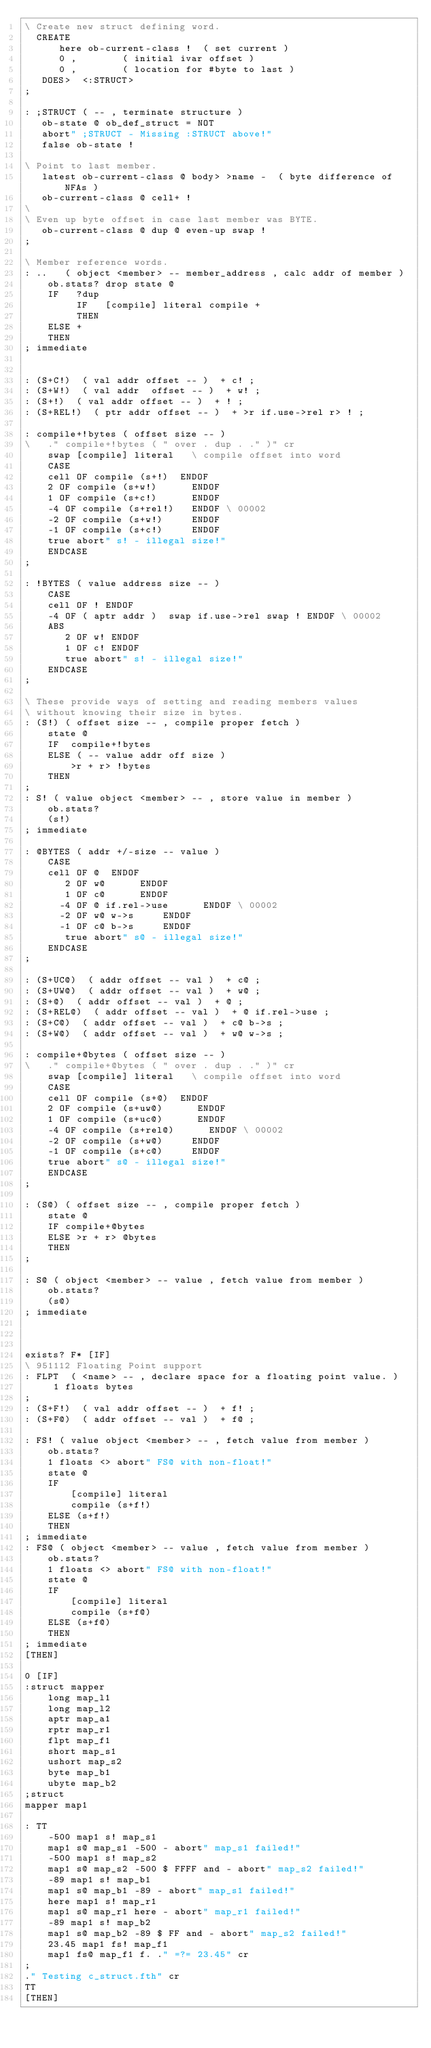Convert code to text. <code><loc_0><loc_0><loc_500><loc_500><_Forth_>\ Create new struct defining word.
  CREATE
      here ob-current-class !  ( set current )
      0 ,        ( initial ivar offset )
      0 ,        ( location for #byte to last )
   DOES>  <:STRUCT>
;

: ;STRUCT ( -- , terminate structure )
   ob-state @ ob_def_struct = NOT
   abort" ;STRUCT - Missing :STRUCT above!"
   false ob-state !

\ Point to last member.
   latest ob-current-class @ body> >name -  ( byte difference of NFAs )
   ob-current-class @ cell+ !
\
\ Even up byte offset in case last member was BYTE.
   ob-current-class @ dup @ even-up swap !
;

\ Member reference words.
: ..   ( object <member> -- member_address , calc addr of member )
    ob.stats? drop state @
    IF   ?dup
         IF   [compile] literal compile +
         THEN
    ELSE +
    THEN
; immediate


: (S+C!)  ( val addr offset -- )  + c! ;
: (S+W!)  ( val addr  offset -- )  + w! ;
: (S+!)  ( val addr offset -- )  + ! ;
: (S+REL!)  ( ptr addr offset -- )  + >r if.use->rel r> ! ;

: compile+!bytes ( offset size -- )
\	." compile+!bytes ( " over . dup . ." )" cr
	swap [compile] literal   \ compile offset into word
	CASE
	cell OF compile (s+!)  ENDOF
	2 OF compile (s+w!)      ENDOF
	1 OF compile (s+c!)      ENDOF
	-4 OF compile (s+rel!)   ENDOF \ 00002
	-2 OF compile (s+w!)     ENDOF
	-1 OF compile (s+c!)     ENDOF
	true abort" s! - illegal size!"
	ENDCASE
;

: !BYTES ( value address size -- )
    CASE
    cell OF ! ENDOF
	-4 OF ( aptr addr )  swap if.use->rel swap ! ENDOF \ 00002
	ABS
       2 OF w! ENDOF
       1 OF c! ENDOF
       true abort" s! - illegal size!"
    ENDCASE
;

\ These provide ways of setting and reading members values
\ without knowing their size in bytes.
: (S!) ( offset size -- , compile proper fetch )
	state @
    IF  compile+!bytes 
    ELSE ( -- value addr off size )
        >r + r> !bytes
    THEN
;
: S! ( value object <member> -- , store value in member )
    ob.stats?
	(s!)
; immediate

: @BYTES ( addr +/-size -- value )
    CASE
    cell OF @  ENDOF
       2 OF w@      ENDOF
       1 OF c@      ENDOF
      -4 OF @ if.rel->use      ENDOF \ 00002
      -2 OF w@ w->s     ENDOF
      -1 OF c@ b->s     ENDOF
       true abort" s@ - illegal size!"
    ENDCASE
;

: (S+UC@)  ( addr offset -- val )  + c@ ;
: (S+UW@)  ( addr offset -- val )  + w@ ;
: (S+@)  ( addr offset -- val )  + @ ;
: (S+REL@)  ( addr offset -- val )  + @ if.rel->use ;
: (S+C@)  ( addr offset -- val )  + c@ b->s ;
: (S+W@)  ( addr offset -- val )  + w@ w->s ;

: compile+@bytes ( offset size -- )
\	." compile+@bytes ( " over . dup . ." )" cr
	swap [compile] literal   \ compile offset into word
	CASE
	cell OF compile (s+@)  ENDOF
	2 OF compile (s+uw@)      ENDOF
	1 OF compile (s+uc@)      ENDOF
	-4 OF compile (s+rel@)      ENDOF \ 00002
	-2 OF compile (s+w@)     ENDOF
	-1 OF compile (s+c@)     ENDOF
	true abort" s@ - illegal size!"
	ENDCASE
;

: (S@) ( offset size -- , compile proper fetch )
	state @
	IF compile+@bytes
	ELSE >r + r> @bytes
	THEN
;

: S@ ( object <member> -- value , fetch value from member )
    ob.stats?
	(s@)
; immediate



exists? F* [IF]
\ 951112 Floating Point support
: FLPT  ( <name> -- , declare space for a floating point value. )
     1 floats bytes
;
: (S+F!)  ( val addr offset -- )  + f! ;
: (S+F@)  ( addr offset -- val )  + f@ ;

: FS! ( value object <member> -- , fetch value from member )
    ob.stats?
    1 floats <> abort" FS@ with non-float!"
	state @
	IF
		[compile] literal
		compile (s+f!)
	ELSE (s+f!)
	THEN
; immediate
: FS@ ( object <member> -- value , fetch value from member )
    ob.stats?
    1 floats <> abort" FS@ with non-float!"
	state @
	IF
		[compile] literal
		compile (s+f@)
	ELSE (s+f@)
	THEN
; immediate
[THEN]

0 [IF]
:struct mapper
    long map_l1
    long map_l2
    aptr map_a1
    rptr map_r1
    flpt map_f1
    short map_s1
    ushort map_s2
    byte map_b1
    ubyte map_b2
;struct
mapper map1

: TT
	-500 map1 s! map_s1
	map1 s@ map_s1 -500 - abort" map_s1 failed!"
	-500 map1 s! map_s2
	map1 s@ map_s2 -500 $ FFFF and - abort" map_s2 failed!"
	-89 map1 s! map_b1
	map1 s@ map_b1 -89 - abort" map_s1 failed!"
	here map1 s! map_r1
	map1 s@ map_r1 here - abort" map_r1 failed!"
	-89 map1 s! map_b2
	map1 s@ map_b2 -89 $ FF and - abort" map_s2 failed!"
	23.45 map1 fs! map_f1
	map1 fs@ map_f1 f. ." =?= 23.45" cr
;
." Testing c_struct.fth" cr
TT
[THEN]
</code> 